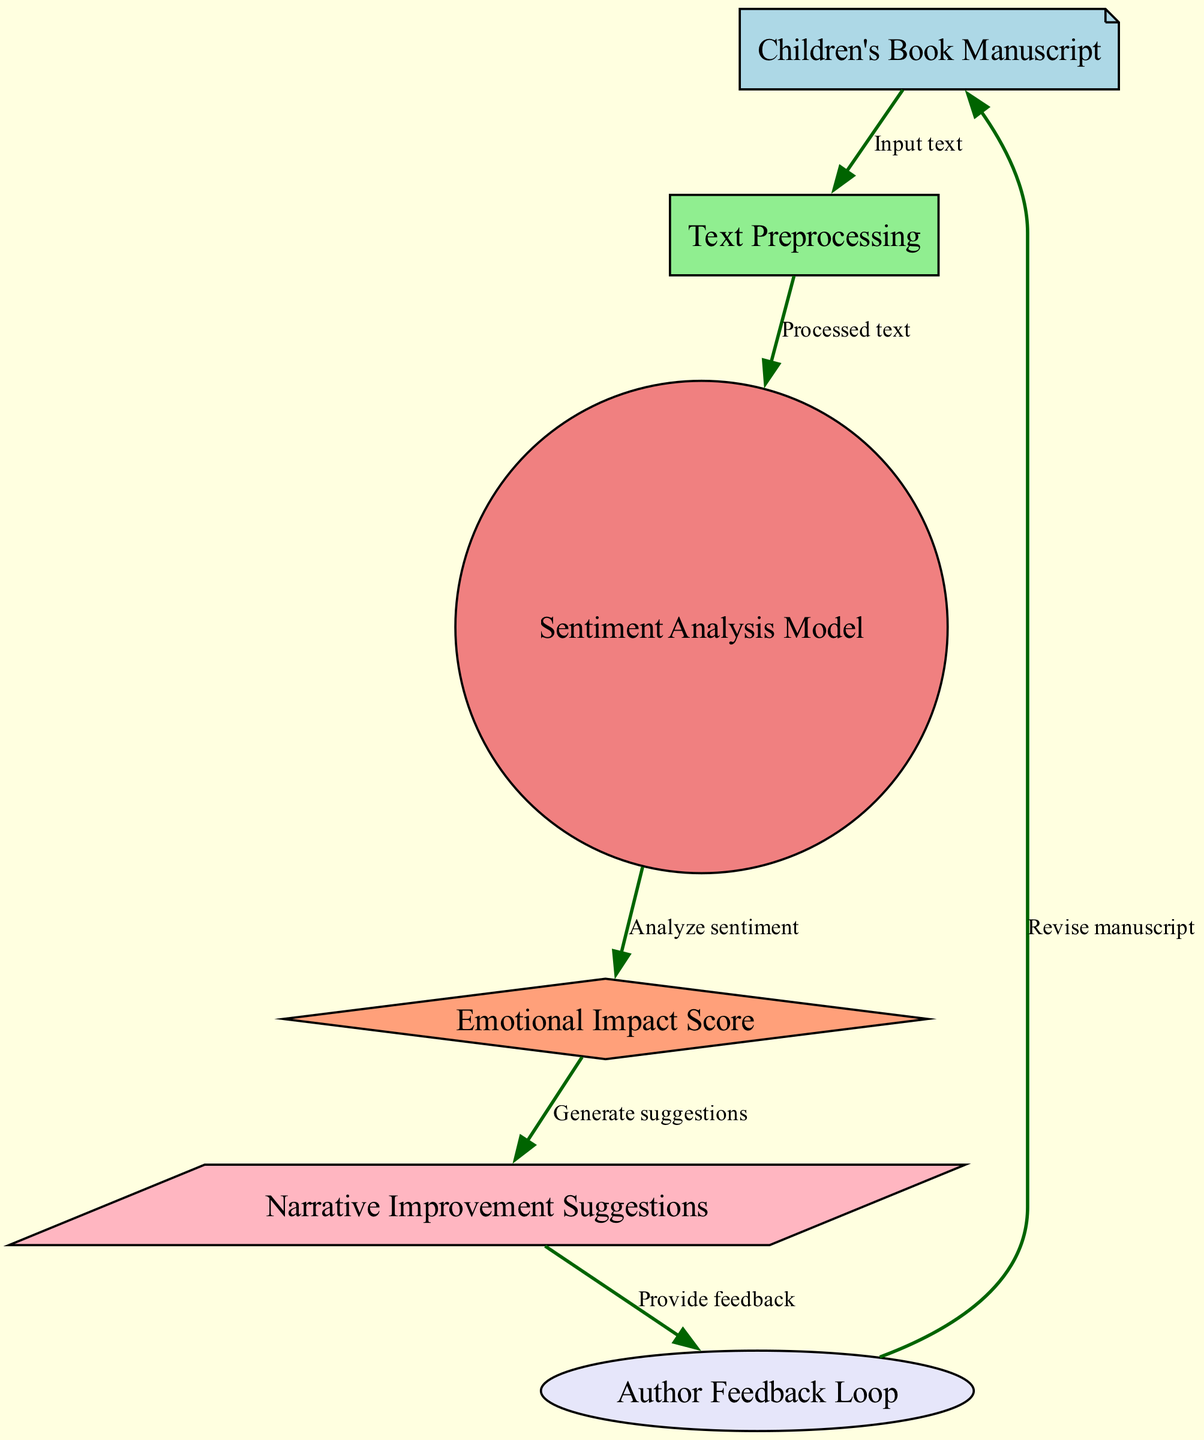What is the first step in the diagram? The first step in the diagram is the "Children's Book Manuscript," which serves as the input text for the analysis process.
Answer: Children's Book Manuscript How many nodes are present in this diagram? There are six nodes in the diagram: "Children's Book Manuscript," "Text Preprocessing," "Sentiment Analysis Model," "Emotional Impact Score," "Narrative Improvement Suggestions," and "Author Feedback Loop."
Answer: Six What is the output of the "Sentiment Analysis Model"? The output of the "Sentiment Analysis Model" is the "Emotional Impact Score," which evaluates the sentiment of the processed text.
Answer: Emotional Impact Score Which node generates suggestions based on the emotional impact? The node that generates suggestions based on the emotional impact is "Narrative Improvement Suggestions," which receives input from the "Emotional Impact Score."
Answer: Narrative Improvement Suggestions What action follows after receiving feedback from the author? After receiving feedback from the author, the next action is to "Revise manuscript," indicating a cycle of improvements based on the feedback.
Answer: Revise manuscript How does the processed text from "Text Preprocessing" travel in the diagram? The processed text moves from "Text Preprocessing" to "Sentiment Analysis Model," indicating that it is the input for sentiment analysis after preprocessing.
Answer: To Sentiment Analysis Model What is the relationship between "Emotional Impact Score" and "Narrative Improvement Suggestions"? The relationship is that the "Emotional Impact Score" provides input to "Narrative Improvement Suggestions," facilitating the generation of suggestions based on sentiment analysis.
Answer: Input provides suggestions What type of feedback is collected from the "Author Feedback Loop"? The feedback collected from the "Author Feedback Loop" is revisions or suggestions on the manuscript based on the improvements suggested after sentiment analysis.
Answer: Revisions or suggestions What can be inferred about the overall purpose of this diagram? The overall purpose of the diagram is to outline a machine learning process that evaluates and improves the emotional impact of children's book narratives through a continuous feedback loop between analysis and revision.
Answer: Evaluate and improve emotional impact 